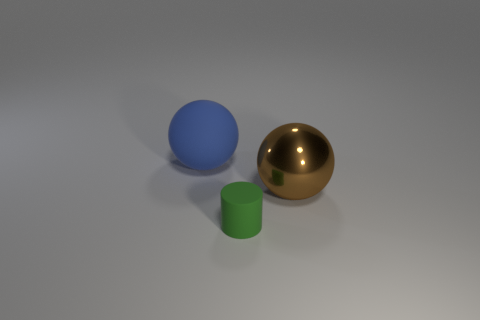Can you describe the lighting and shadows in the image? The image has a relatively soft and diffuse lighting setup with light coming from the upper left, which suggests an indoor scenario with possibly a single light source. This is indicated by soft but defined shadows trailing to the lower right side of each object. The shadows help provide a sense of depth and position of the objects relative to each other. Does the direction of the shadows tell us anything about the light source? Yes, the shadows being cast towards the lower right corner suggest that the light source is situated towards the upper left side of the scene. The soft edges of the shadows indicate that the light source is not extremely close to the objects, and that it might be diffused, like light through a window or a lamp with a shade. 